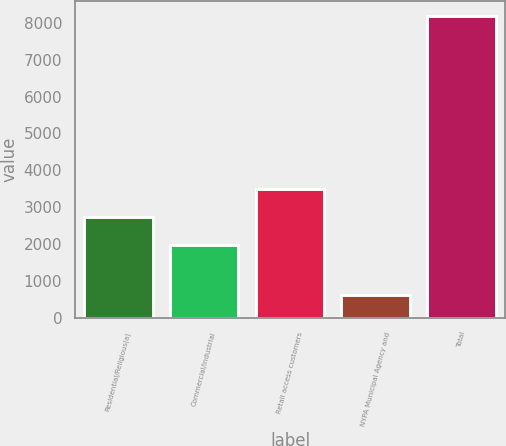Convert chart to OTSL. <chart><loc_0><loc_0><loc_500><loc_500><bar_chart><fcel>Residential/Religious(a)<fcel>Commercial/Industrial<fcel>Retail access customers<fcel>NYPA Municipal Agency and<fcel>Total<nl><fcel>2749<fcel>1971<fcel>3504.9<fcel>617<fcel>8176<nl></chart> 